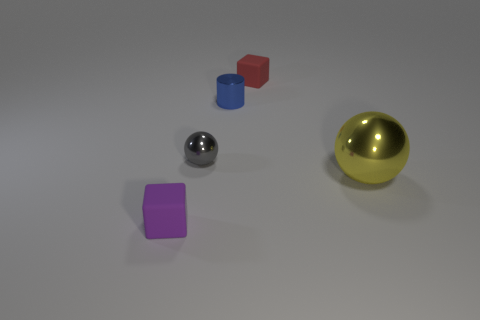Does the image have any identifiable textures or patterns? The objects display solid colors without any noticeable patterns. The textures are distinguishable by the way they reflect light: the metallic objects have a smooth and reflective surface, while the colored cube and cylinder appear to have a matte finish.  Is there any indication of what materials the objects are made from based on their appearance? Based on their appearance, the sphere and the small gray object seem to be made of a metallic material due to their reflective surface. The blue cylinder and the red cube look like they are made of a plastic or non-metal material due to the matte finish and absence of reflection. 